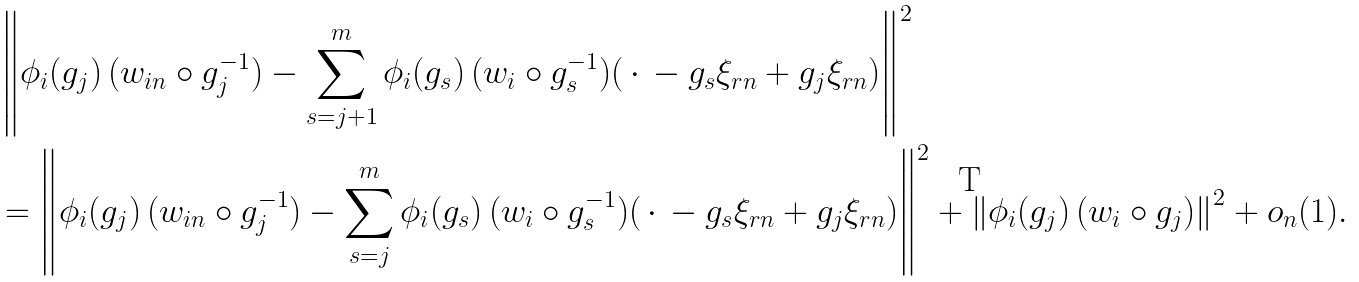<formula> <loc_0><loc_0><loc_500><loc_500>& \left \| \phi _ { i } ( g _ { j } ) \, ( w _ { i n } \circ g _ { j } ^ { - 1 } ) - \sum _ { s = j + 1 } ^ { m } \phi _ { i } ( g _ { s } ) \, ( w _ { i } \circ g _ { s } ^ { - 1 } ) ( \, \cdot \, - g _ { s } \xi _ { r n } + g _ { j } \xi _ { r n } ) \right \| ^ { 2 } \\ & = \left \| \phi _ { i } ( g _ { j } ) \, ( w _ { i n } \circ g _ { j } ^ { - 1 } ) - \sum _ { s = j } ^ { m } \phi _ { i } ( g _ { s } ) \, ( w _ { i } \circ g _ { s } ^ { - 1 } ) ( \, \cdot \, - g _ { s } \xi _ { r n } + g _ { j } \xi _ { r n } ) \right \| ^ { 2 } + \left \| \phi _ { i } ( g _ { j } ) \, ( w _ { i } \circ g _ { j } ) \right \| ^ { 2 } + o _ { n } ( 1 ) .</formula> 